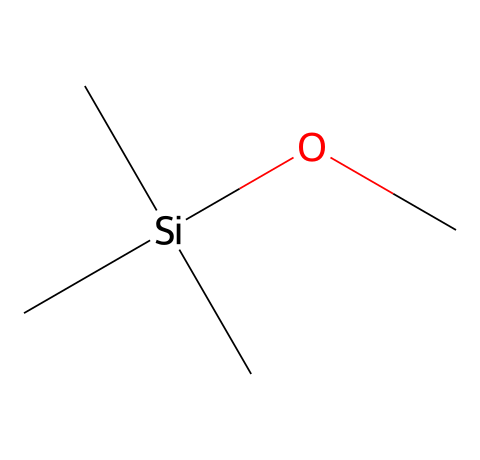what is the central atom in this compound? The structure shows that the silicon atom is located at the center, as indicated by its connectivity to surrounding atoms (three carbon atoms and one oxygen atom).
Answer: silicon how many carbon atoms are present? The SMILES representation shows three carbon atoms connected to the silicon atom. Counting these gives us the total number of carbon atoms.
Answer: three what type of functional group is present in this molecule? The presence of the -O- (oxygen) bonded to the silicon atom indicates that this compound has an alkoxy functional group (specifically a methoxy group, as it's connected to a carbon atom).
Answer: alkoxy what is the degree of branching in this molecular structure? The structure has three methyl groups (the three carbon atoms surrounding the silicon atom) which indicates that it is highly branched, with a central silicon atom surrounded by three carbon atoms.
Answer: highly branched how many total atoms are in this molecule? By counting the atoms in the chemical structure: 3 carbon, 1 silicon, and 1 oxygen gives a total of 5 atoms.
Answer: five is this compound polar or nonpolar? The arrangement of groups around the silicon leads to a symmetrical structure, which typically results in a nonpolar character. The lack of polar bonds in the overall molecule supports this conclusion.
Answer: nonpolar 